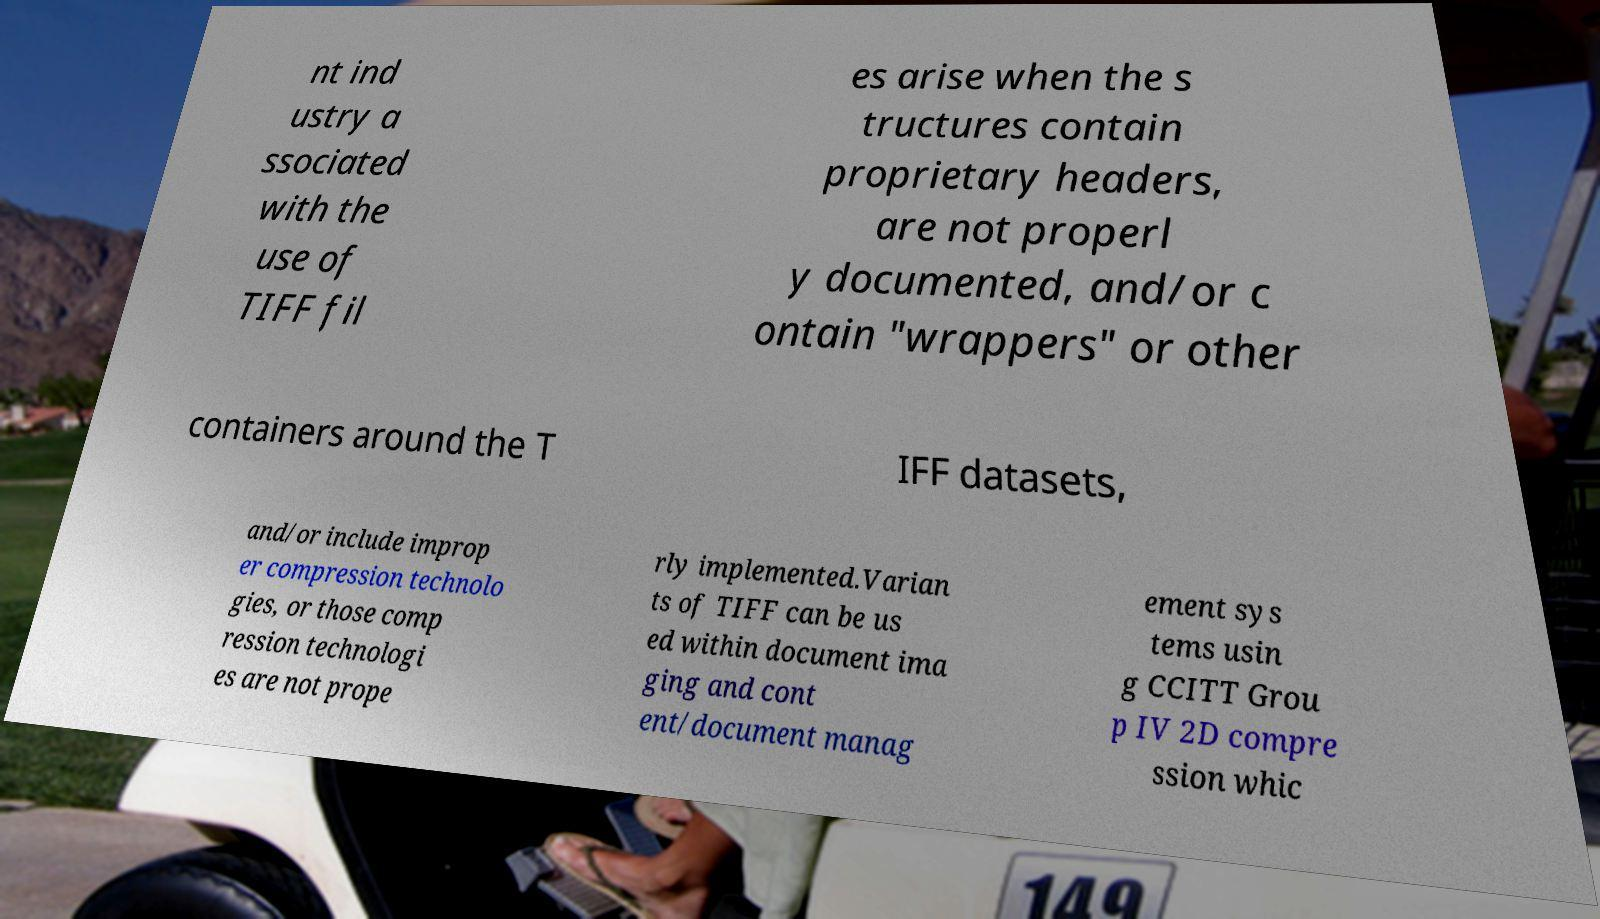Could you extract and type out the text from this image? nt ind ustry a ssociated with the use of TIFF fil es arise when the s tructures contain proprietary headers, are not properl y documented, and/or c ontain "wrappers" or other containers around the T IFF datasets, and/or include improp er compression technolo gies, or those comp ression technologi es are not prope rly implemented.Varian ts of TIFF can be us ed within document ima ging and cont ent/document manag ement sys tems usin g CCITT Grou p IV 2D compre ssion whic 